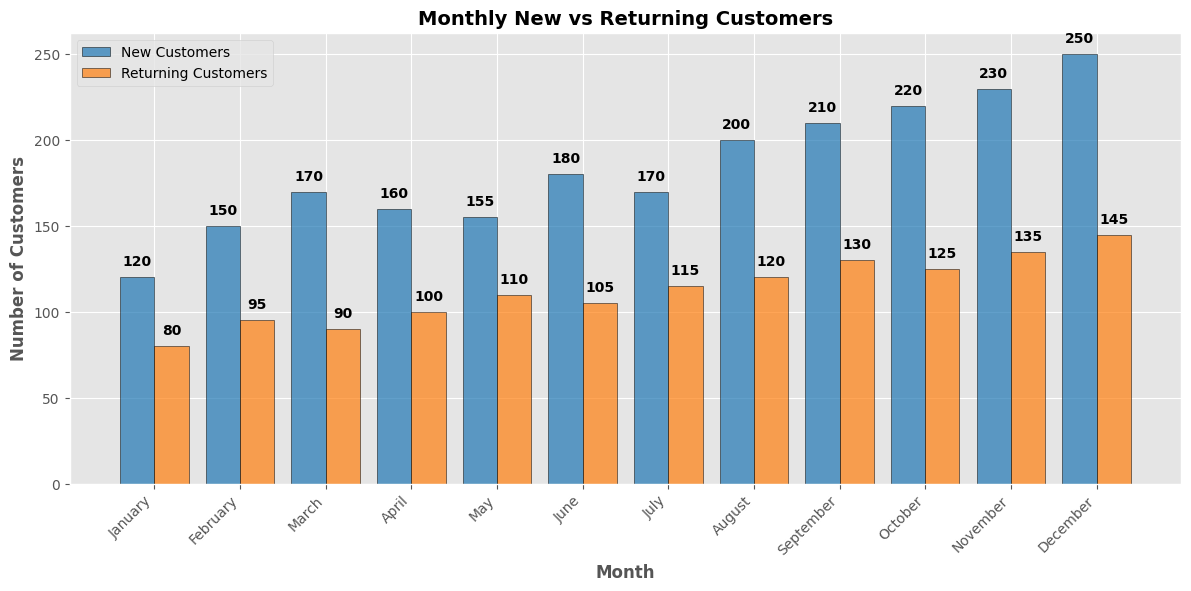What's the total number of new customers for the year? Sum the number of new customers for each month: 120 + 150 + 170 + 160 + 155 + 180 + 170 + 200 + 210 + 220 + 230 + 250 = 2215
Answer: 2215 Which month had the highest number of returning customers? Identify the tallest orange bar representing returning customers and find the corresponding month. December's bar is the tallest among the returning customers
Answer: December By how much did the number of new customers increase from January to December? Subtract the number of new customers in January from the number in December: 250 (December) - 120 (January) = 130
Answer: 130 Which month had more new customers than returning customers, the highest difference? Look for the month where the blue bar (new customers) is significantly higher than the orange bar (returning customers) and calculate the difference for each month: August = 200 - 120 = 80, which is the highest
Answer: August What is the average number of returning customers per month? Sum the number of returning customers and divide by 12: (80 + 95 + 90 + 100 + 110 + 105 + 115 + 120 + 130 + 125 + 135 + 145) / 12 = 115
Answer: 115 In which month was the gap between new and returning customers the smallest? Compare the differences for each month: January = 120 - 80 = 40, February = 150 - 95 = 55, ..., December = 250 - 145 = 105. April has the smallest gap: 160 - 100 = 60.
Answer: January What's the mid-year (June) new to returning customers ratio? Find the values for June and divide the new customers by returning customers: 180 (new) / 105 (returning) ≈ 1.71
Answer: 1.71 How many months had more new customers than the annual average of returning customers? Find the annual average of returning customers first: 115. Check each month: January (120 > 115), February (150 > 115), ..., December (250 > 115). Count the months: All 12 months
Answer: 12 Which month saw the least difference between new and returning customers? Identify the month with the smallest difference: January (120 - 80 = 40), February (150 - 95 = 55), April (160 - 100 = 60), ... March (170 - 90 = 80). The smallest difference is 40 for January
Answer: January 